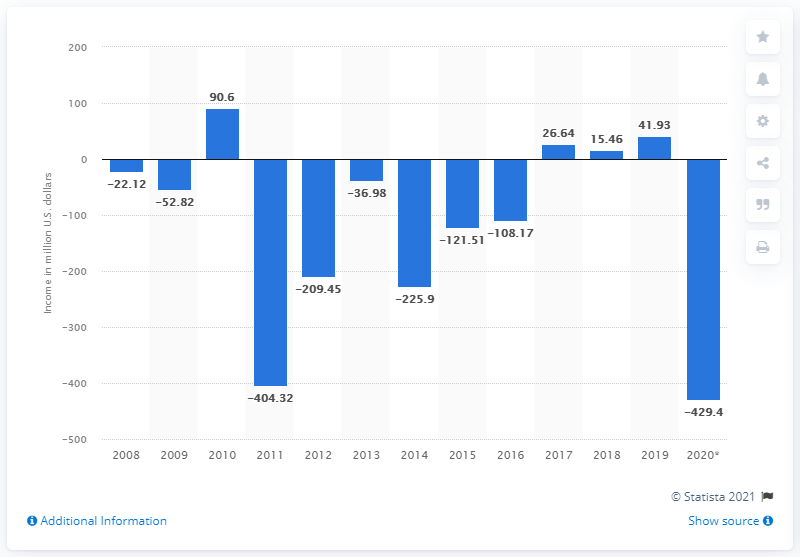Mention a couple of crucial points in this snapshot. In the previous year, Zynga's net income was 41.93 million dollars. 